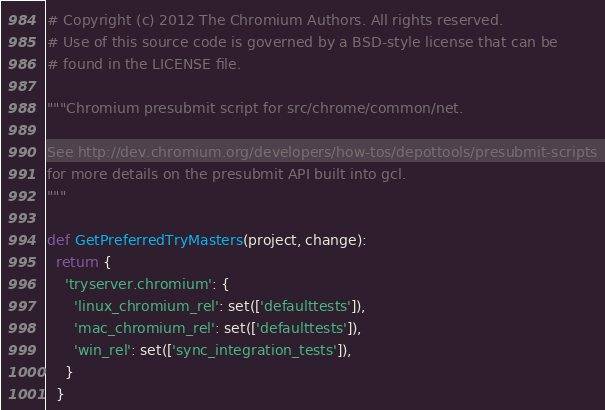<code> <loc_0><loc_0><loc_500><loc_500><_Python_># Copyright (c) 2012 The Chromium Authors. All rights reserved.
# Use of this source code is governed by a BSD-style license that can be
# found in the LICENSE file.

"""Chromium presubmit script for src/chrome/common/net.

See http://dev.chromium.org/developers/how-tos/depottools/presubmit-scripts
for more details on the presubmit API built into gcl.
"""

def GetPreferredTryMasters(project, change):
  return {
    'tryserver.chromium': {
      'linux_chromium_rel': set(['defaulttests']),
      'mac_chromium_rel': set(['defaulttests']),
      'win_rel': set(['sync_integration_tests']),
    }
  }
</code> 